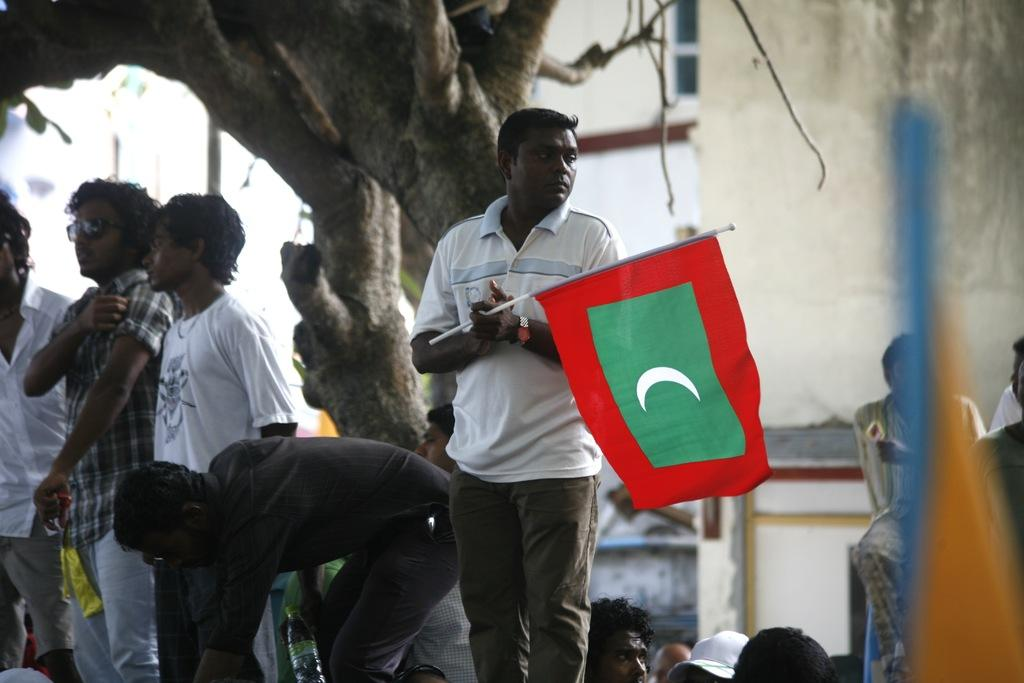How many people are in the image? There is a group of people in the image, but the exact number is not specified. What is the person holding in the image? The person is holding a flag in the image. What type of natural elements can be seen in the image? Tree trunks are visible in the image. What type of structure is present in the image? There is a building in the image. What type of meat is being served at the feast in the image? There is no feast or meat present in the image. How many trucks are visible in the image? There are no trucks visible in the image. 